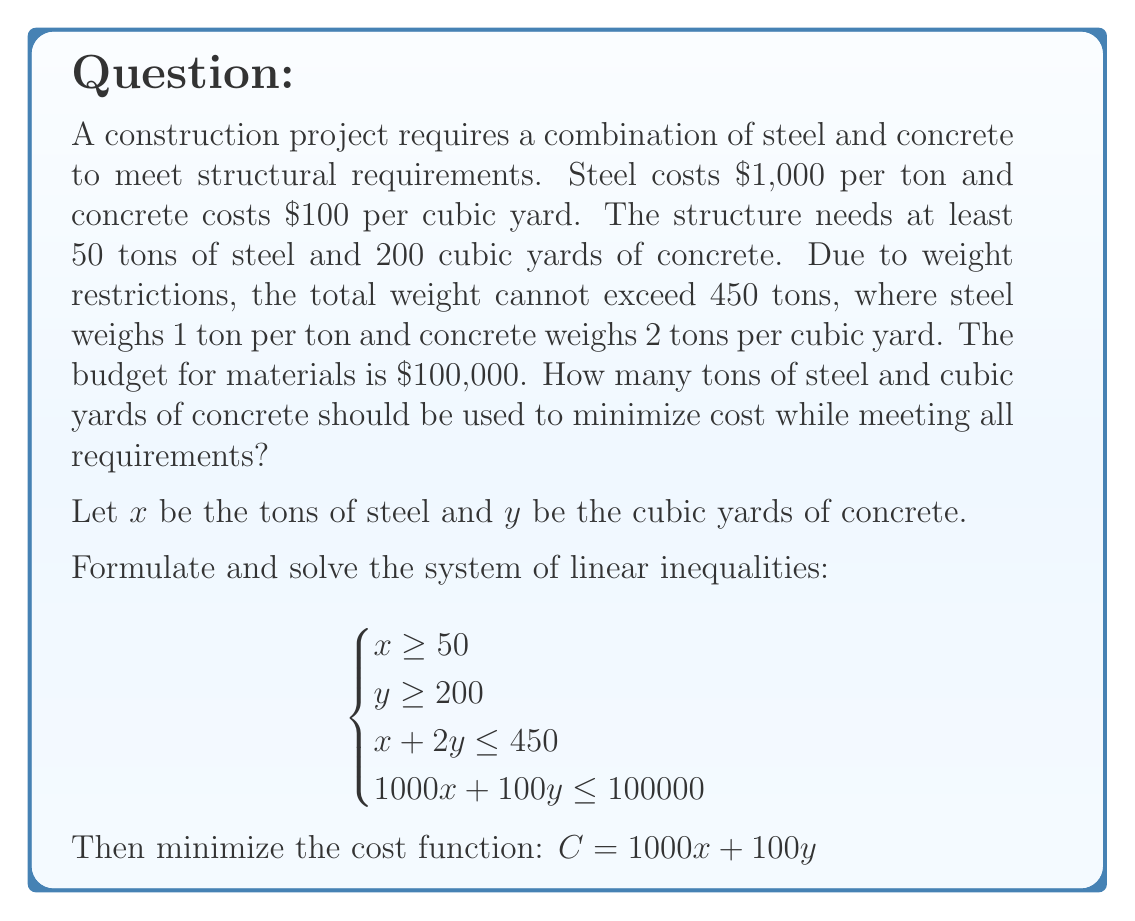Help me with this question. Step 1: Set up the system of inequalities
$$\begin{cases}
x \geq 50 \\
y \geq 200 \\
x + 2y \leq 450 \\
1000x + 100y \leq 100000
\end{cases}$$

Step 2: Identify the feasible region
The feasible region is the area that satisfies all inequalities.

Step 3: Find the vertices of the feasible region
We can find the intersection points of the lines:
- $(50, 200)$ (minimum steel and concrete)
- $(50, 200)$ and $x + 2y = 450$: $(50, 200)$
- $(50, 200)$ and $1000x + 100y = 100000$: $(75, 250)$
- $x + 2y = 450$ and $1000x + 100y = 100000$: $(70, 190)$

Step 4: Evaluate the cost function at each vertex
- $C(50, 200) = 1000(50) + 100(200) = 70,000$
- $C(75, 250) = 1000(75) + 100(250) = 100,000$
- $C(70, 190) = 1000(70) + 100(190) = 89,000$

Step 5: Choose the minimum cost
The minimum cost occurs at the point $(50, 200)$, which corresponds to 50 tons of steel and 200 cubic yards of concrete.
Answer: 50 tons of steel, 200 cubic yards of concrete 